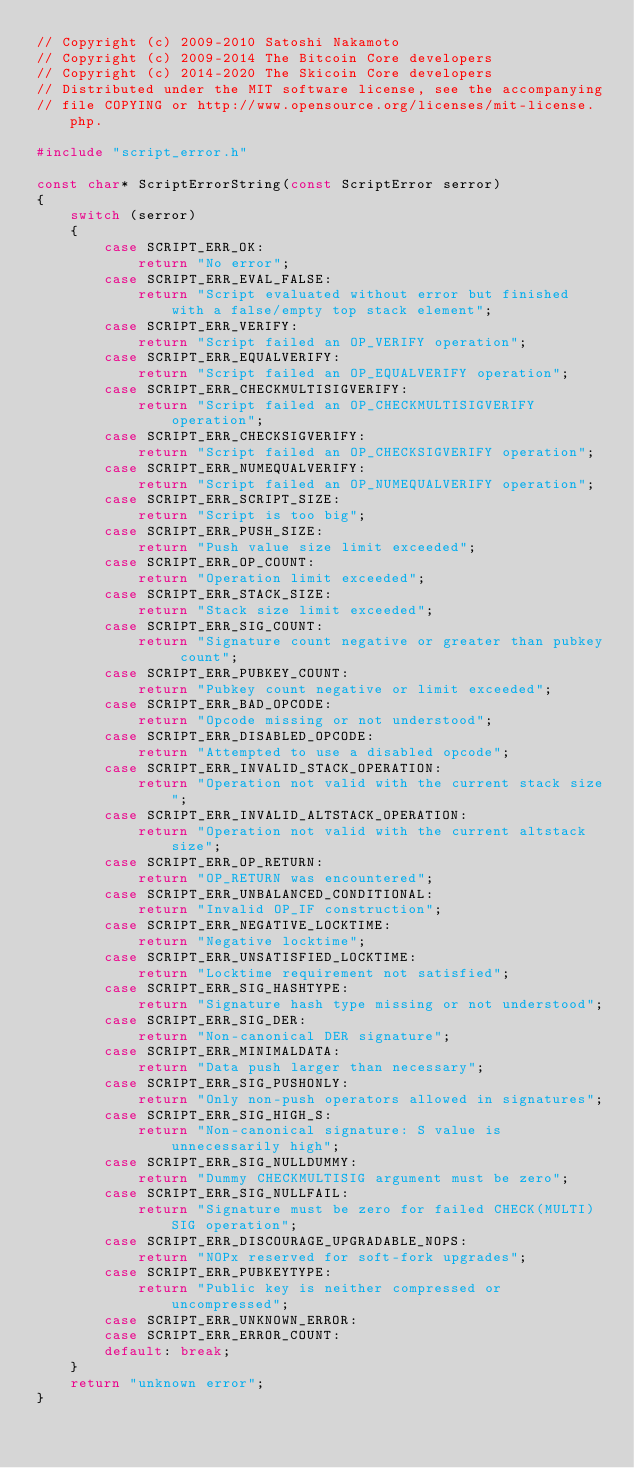<code> <loc_0><loc_0><loc_500><loc_500><_C++_>// Copyright (c) 2009-2010 Satoshi Nakamoto
// Copyright (c) 2009-2014 The Bitcoin Core developers
// Copyright (c) 2014-2020 The Skicoin Core developers
// Distributed under the MIT software license, see the accompanying
// file COPYING or http://www.opensource.org/licenses/mit-license.php.

#include "script_error.h"

const char* ScriptErrorString(const ScriptError serror)
{
    switch (serror)
    {
        case SCRIPT_ERR_OK:
            return "No error";
        case SCRIPT_ERR_EVAL_FALSE:
            return "Script evaluated without error but finished with a false/empty top stack element";
        case SCRIPT_ERR_VERIFY:
            return "Script failed an OP_VERIFY operation";
        case SCRIPT_ERR_EQUALVERIFY:
            return "Script failed an OP_EQUALVERIFY operation";
        case SCRIPT_ERR_CHECKMULTISIGVERIFY:
            return "Script failed an OP_CHECKMULTISIGVERIFY operation";
        case SCRIPT_ERR_CHECKSIGVERIFY:
            return "Script failed an OP_CHECKSIGVERIFY operation";
        case SCRIPT_ERR_NUMEQUALVERIFY:
            return "Script failed an OP_NUMEQUALVERIFY operation";
        case SCRIPT_ERR_SCRIPT_SIZE:
            return "Script is too big";
        case SCRIPT_ERR_PUSH_SIZE:
            return "Push value size limit exceeded";
        case SCRIPT_ERR_OP_COUNT:
            return "Operation limit exceeded";
        case SCRIPT_ERR_STACK_SIZE:
            return "Stack size limit exceeded";
        case SCRIPT_ERR_SIG_COUNT:
            return "Signature count negative or greater than pubkey count";
        case SCRIPT_ERR_PUBKEY_COUNT:
            return "Pubkey count negative or limit exceeded";
        case SCRIPT_ERR_BAD_OPCODE:
            return "Opcode missing or not understood";
        case SCRIPT_ERR_DISABLED_OPCODE:
            return "Attempted to use a disabled opcode";
        case SCRIPT_ERR_INVALID_STACK_OPERATION:
            return "Operation not valid with the current stack size";
        case SCRIPT_ERR_INVALID_ALTSTACK_OPERATION:
            return "Operation not valid with the current altstack size";
        case SCRIPT_ERR_OP_RETURN:
            return "OP_RETURN was encountered";
        case SCRIPT_ERR_UNBALANCED_CONDITIONAL:
            return "Invalid OP_IF construction";
        case SCRIPT_ERR_NEGATIVE_LOCKTIME:
            return "Negative locktime";
        case SCRIPT_ERR_UNSATISFIED_LOCKTIME:
            return "Locktime requirement not satisfied";
        case SCRIPT_ERR_SIG_HASHTYPE:
            return "Signature hash type missing or not understood";
        case SCRIPT_ERR_SIG_DER:
            return "Non-canonical DER signature";
        case SCRIPT_ERR_MINIMALDATA:
            return "Data push larger than necessary";
        case SCRIPT_ERR_SIG_PUSHONLY:
            return "Only non-push operators allowed in signatures";
        case SCRIPT_ERR_SIG_HIGH_S:
            return "Non-canonical signature: S value is unnecessarily high";
        case SCRIPT_ERR_SIG_NULLDUMMY:
            return "Dummy CHECKMULTISIG argument must be zero";
        case SCRIPT_ERR_SIG_NULLFAIL:
            return "Signature must be zero for failed CHECK(MULTI)SIG operation";
        case SCRIPT_ERR_DISCOURAGE_UPGRADABLE_NOPS:
            return "NOPx reserved for soft-fork upgrades";
        case SCRIPT_ERR_PUBKEYTYPE:
            return "Public key is neither compressed or uncompressed";
        case SCRIPT_ERR_UNKNOWN_ERROR:
        case SCRIPT_ERR_ERROR_COUNT:
        default: break;
    }
    return "unknown error";
}
</code> 